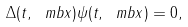<formula> <loc_0><loc_0><loc_500><loc_500>\Delta ( t , \ m b { x } ) \psi ( t , \ m b { x } ) = 0 ,</formula> 